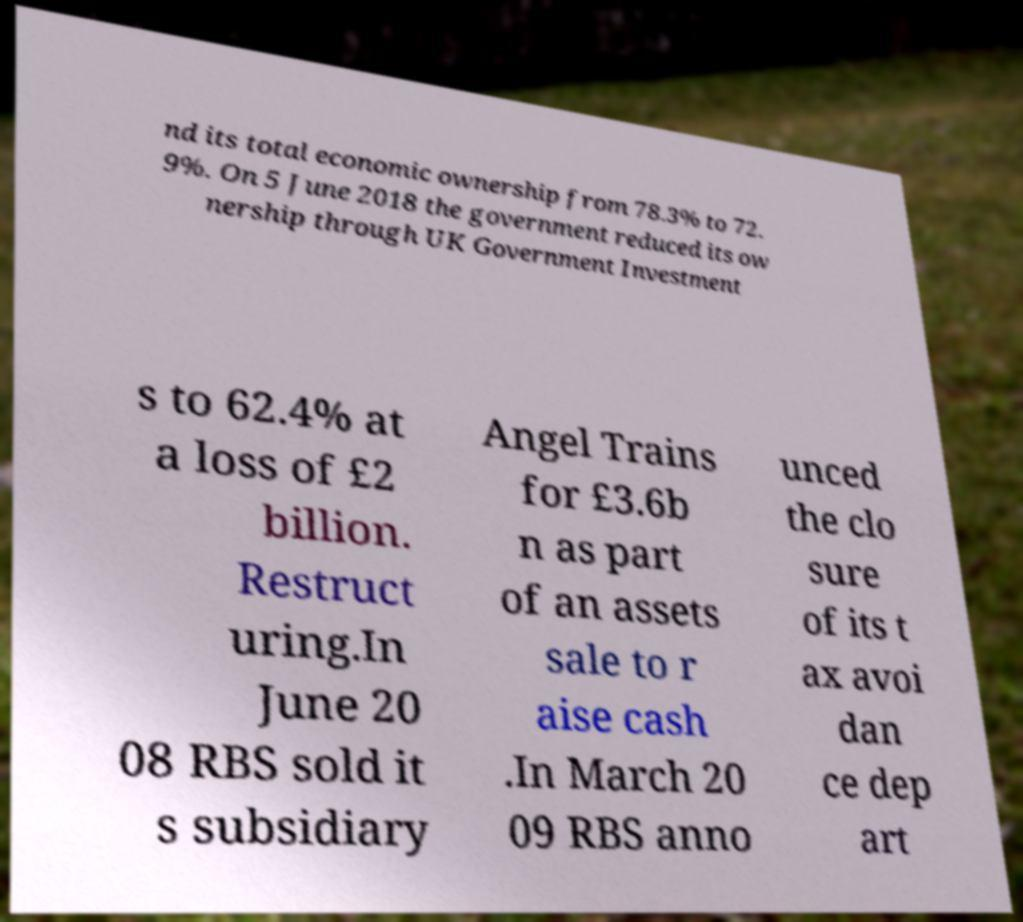Please read and relay the text visible in this image. What does it say? nd its total economic ownership from 78.3% to 72. 9%. On 5 June 2018 the government reduced its ow nership through UK Government Investment s to 62.4% at a loss of £2 billion. Restruct uring.In June 20 08 RBS sold it s subsidiary Angel Trains for £3.6b n as part of an assets sale to r aise cash .In March 20 09 RBS anno unced the clo sure of its t ax avoi dan ce dep art 